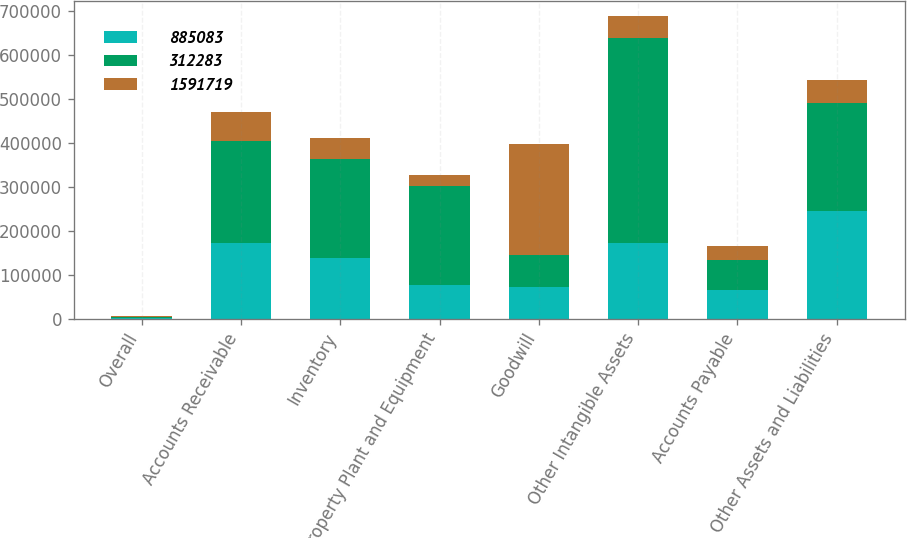Convert chart. <chart><loc_0><loc_0><loc_500><loc_500><stacked_bar_chart><ecel><fcel>Overall<fcel>Accounts Receivable<fcel>Inventory<fcel>Property Plant and Equipment<fcel>Goodwill<fcel>Other Intangible Assets<fcel>Accounts Payable<fcel>Other Assets and Liabilities<nl><fcel>885083<fcel>2005<fcel>171978<fcel>138626<fcel>77088<fcel>72266<fcel>172362<fcel>65706<fcel>245162<nl><fcel>312283<fcel>2004<fcel>232696<fcel>224703<fcel>224685<fcel>72266<fcel>466902<fcel>67444<fcel>245826<nl><fcel>1.59172e+06<fcel>2003<fcel>64794<fcel>48366<fcel>25163<fcel>253503<fcel>48468<fcel>31061<fcel>52342<nl></chart> 